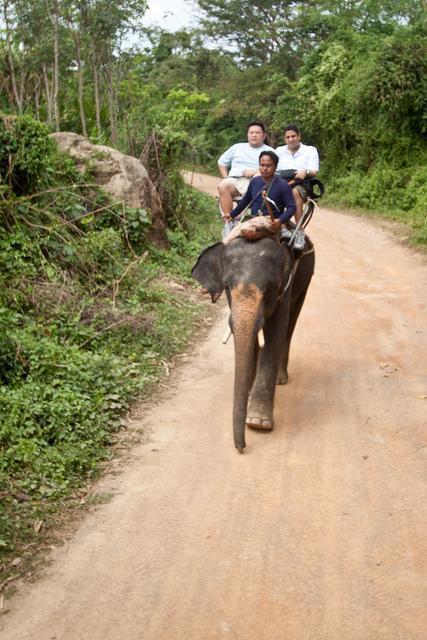How many elephants are there?
Give a very brief answer. 1. How many people are visible?
Give a very brief answer. 3. 